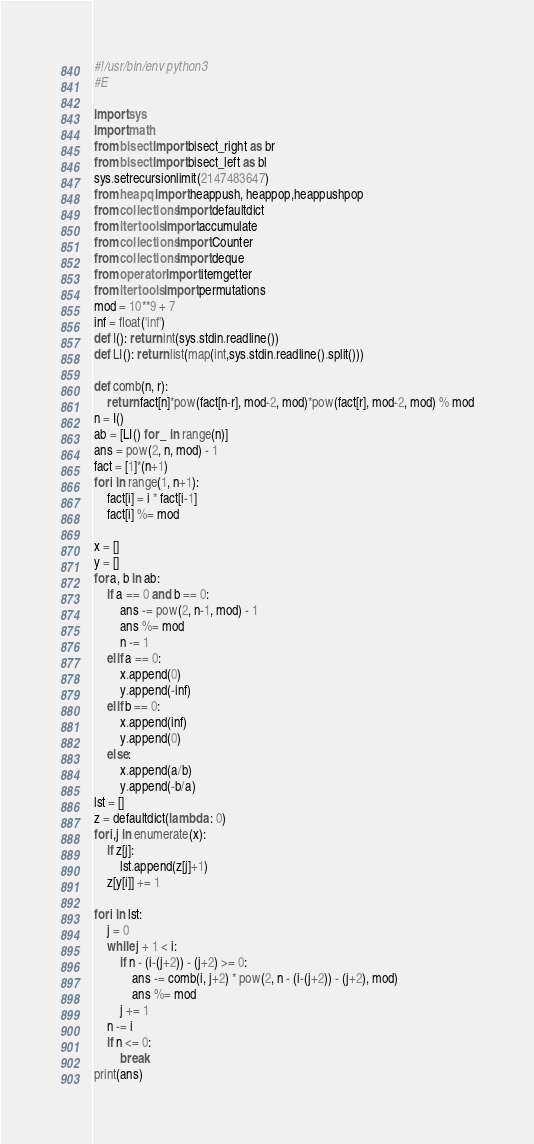Convert code to text. <code><loc_0><loc_0><loc_500><loc_500><_Python_>#!/usr/bin/env python3
#E

import sys
import math
from bisect import bisect_right as br
from bisect import bisect_left as bl
sys.setrecursionlimit(2147483647)
from heapq import heappush, heappop,heappushpop
from collections import defaultdict
from itertools import accumulate
from collections import Counter
from collections import deque
from operator import itemgetter
from itertools import permutations
mod = 10**9 + 7
inf = float('inf')
def I(): return int(sys.stdin.readline())
def LI(): return list(map(int,sys.stdin.readline().split()))

def comb(n, r):
    return fact[n]*pow(fact[n-r], mod-2, mod)*pow(fact[r], mod-2, mod) % mod
n = I()
ab = [LI() for _ in range(n)]
ans = pow(2, n, mod) - 1
fact = [1]*(n+1)
for i in range(1, n+1):
    fact[i] = i * fact[i-1]
    fact[i] %= mod

x = []
y = []
for a, b in ab:
    if a == 0 and b == 0:
        ans -= pow(2, n-1, mod) - 1
        ans %= mod
        n -= 1
    elif a == 0:
        x.append(0)
        y.append(-inf)
    elif b == 0:
        x.append(inf)
        y.append(0)
    else:
        x.append(a/b)
        y.append(-b/a)
lst = []
z = defaultdict(lambda : 0)
for i,j in enumerate(x):
    if z[j]:
        lst.append(z[j]+1)
    z[y[i]] += 1

for i in lst:
    j = 0
    while j + 1 < i:
        if n - (i-(j+2)) - (j+2) >= 0:
            ans -= comb(i, j+2) * pow(2, n - (i-(j+2)) - (j+2), mod)
            ans %= mod
        j += 1
    n -= i
    if n <= 0:
        break
print(ans)


</code> 